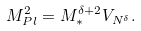<formula> <loc_0><loc_0><loc_500><loc_500>M _ { P l } ^ { 2 } = M _ { * } ^ { \delta + 2 } V _ { N ^ { \delta } } .</formula> 